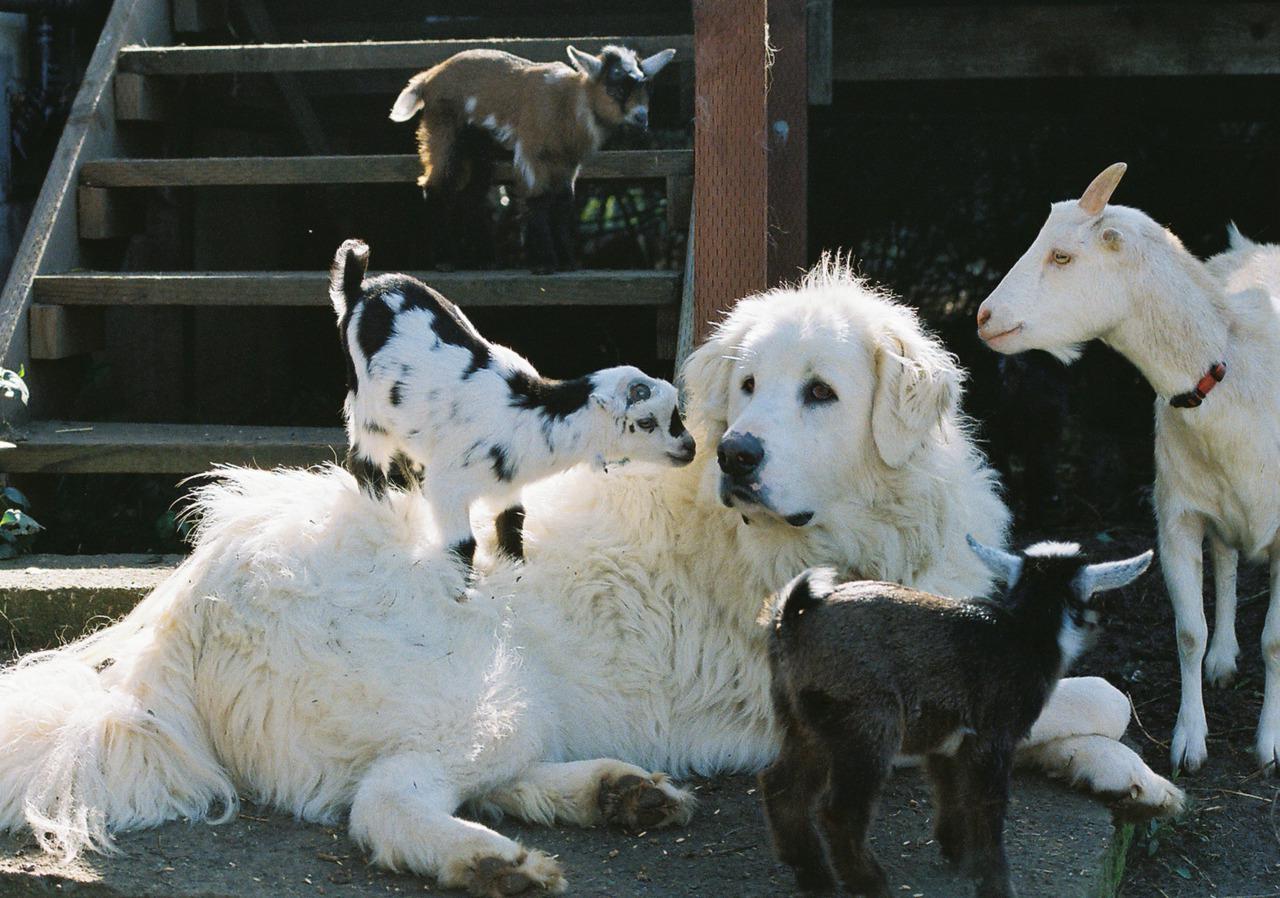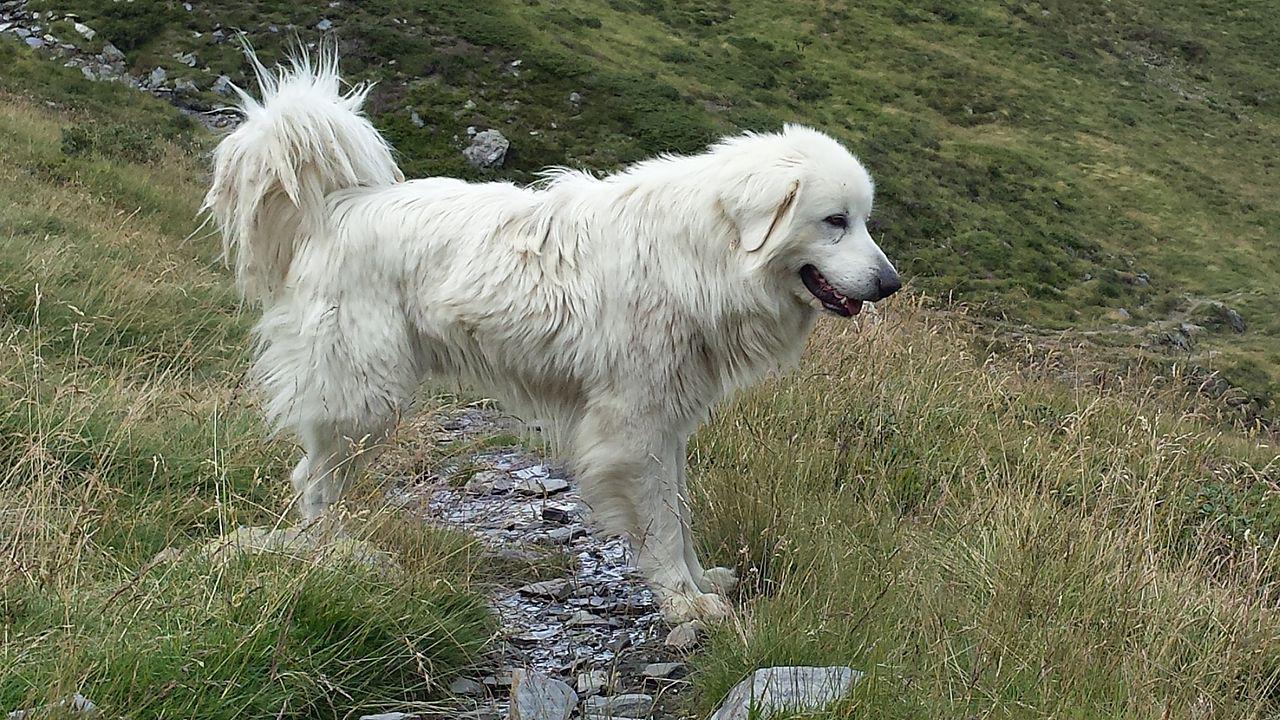The first image is the image on the left, the second image is the image on the right. Considering the images on both sides, is "An image shows a white dog behind a wire fence with a herd of livestock." valid? Answer yes or no. No. The first image is the image on the left, the second image is the image on the right. For the images shown, is this caption "There is a baby goat on a dog in one of the images." true? Answer yes or no. Yes. 